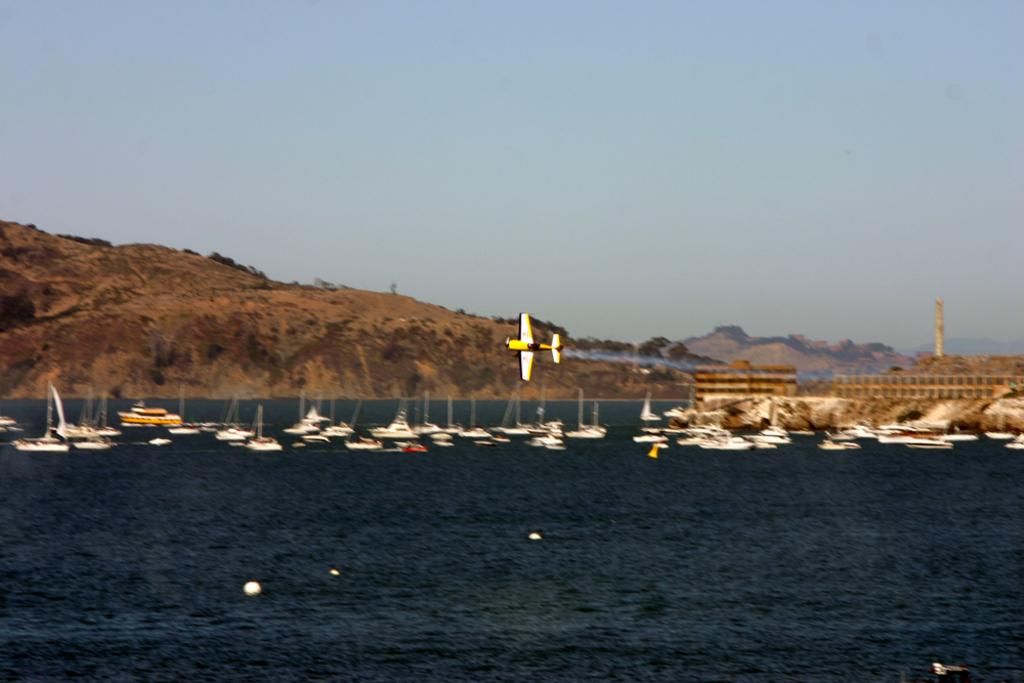What type of vehicles are in the water in the image? There are boats in the water in the image. What part of the natural environment is visible in the image? The sky is visible in the image. What type of band can be seen performing on the boats in the image? There is no band present on the boats in the image. What material is the glass used for the boats made of in the image? There is no glass or reference to glass in the image; the boats are likely made of materials such as wood or fiberglass. 